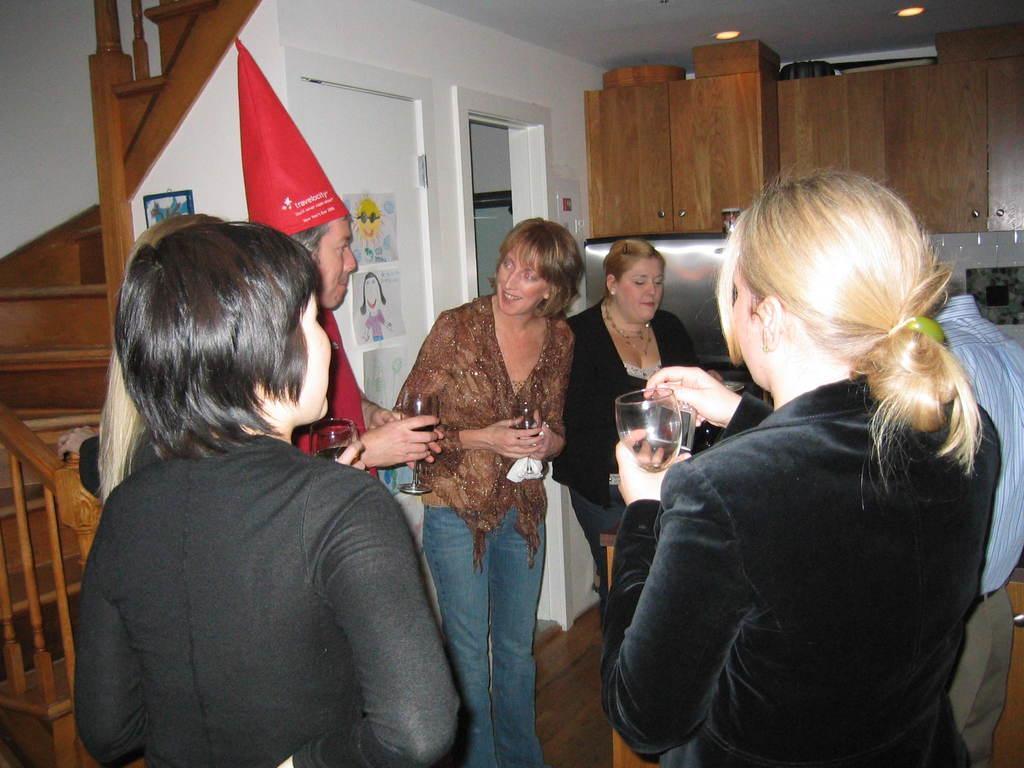In one or two sentences, can you explain what this image depicts? In this image I can see number of persons are standing on the ground and I can see they are holding wine glasses in their hands. In the background I can see the wall, the door, few posts attached to the door, the ceiling, few lights to the ceiling, few wooden cabinets, few stairs and the railing. 